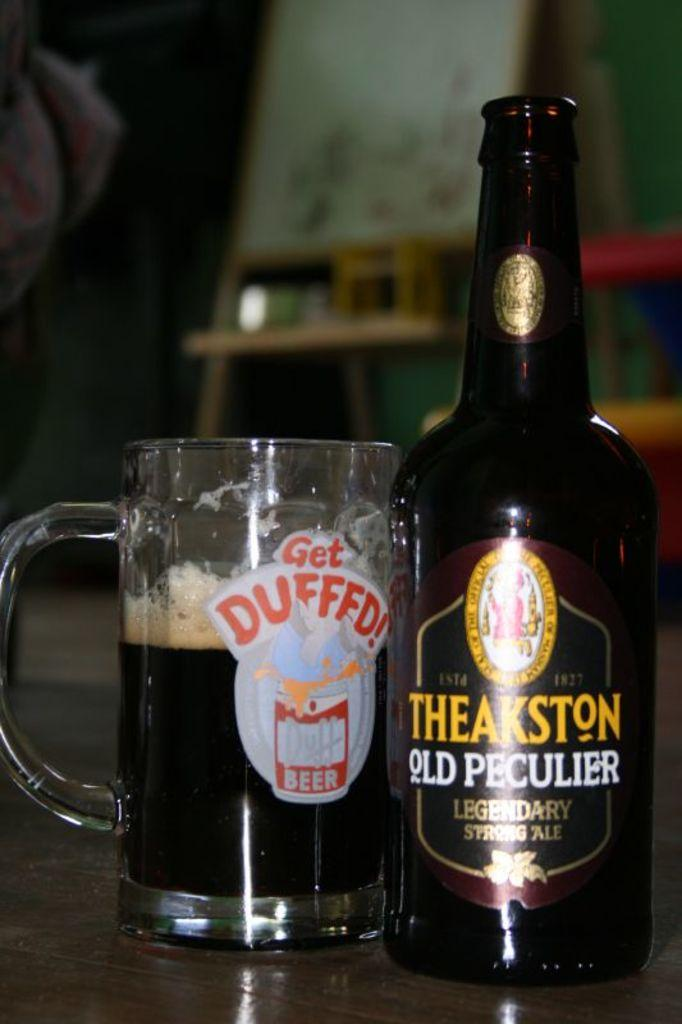<image>
Share a concise interpretation of the image provided. a bottle of theakston old peculier legendary strong ale 